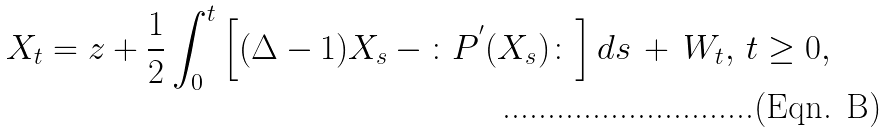Convert formula to latex. <formula><loc_0><loc_0><loc_500><loc_500>X _ { t } = z + \frac { 1 } { 2 } \int _ { 0 } ^ { t } \left [ ( \Delta - 1 ) X _ { s } \, - \, \colon P ^ { ^ { \prime } } ( X _ { s } ) \colon \right ] d s \, + \, W _ { t } , \, t \geq 0 ,</formula> 